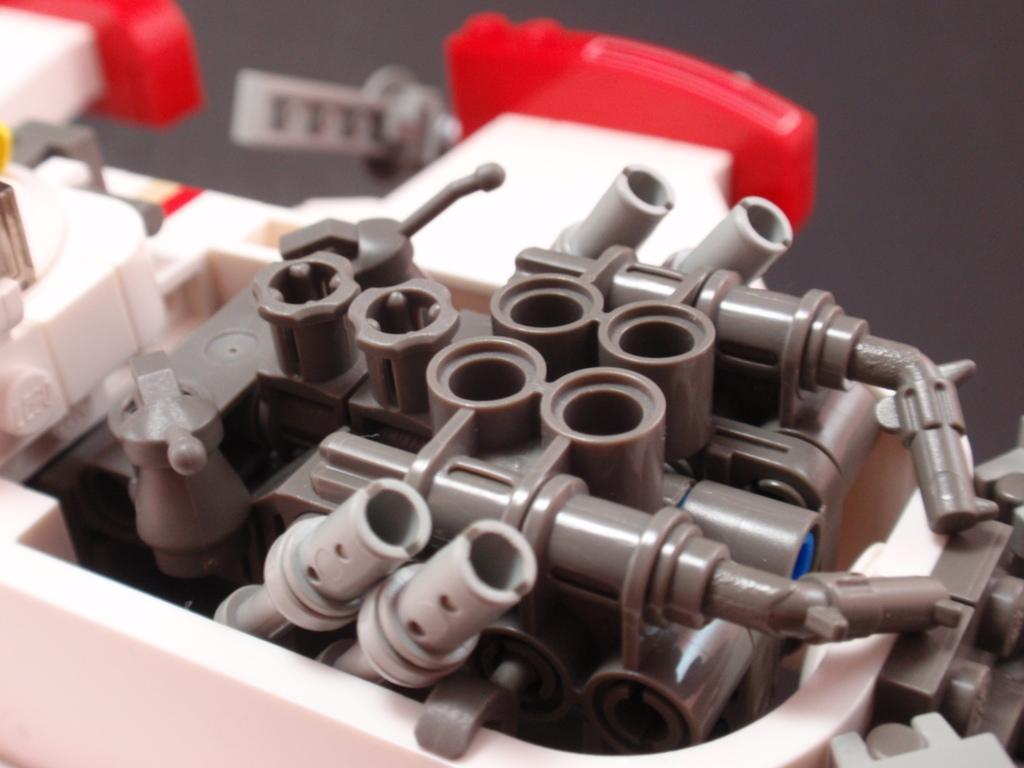What type of objects are present in the image? There are tool parts in the image. What colors can be seen in the tool parts? The tool parts are in grey, white, and red colors. Are there any trees visible in the image? No, there are no trees present in the image; it only features tool parts in different colors. 